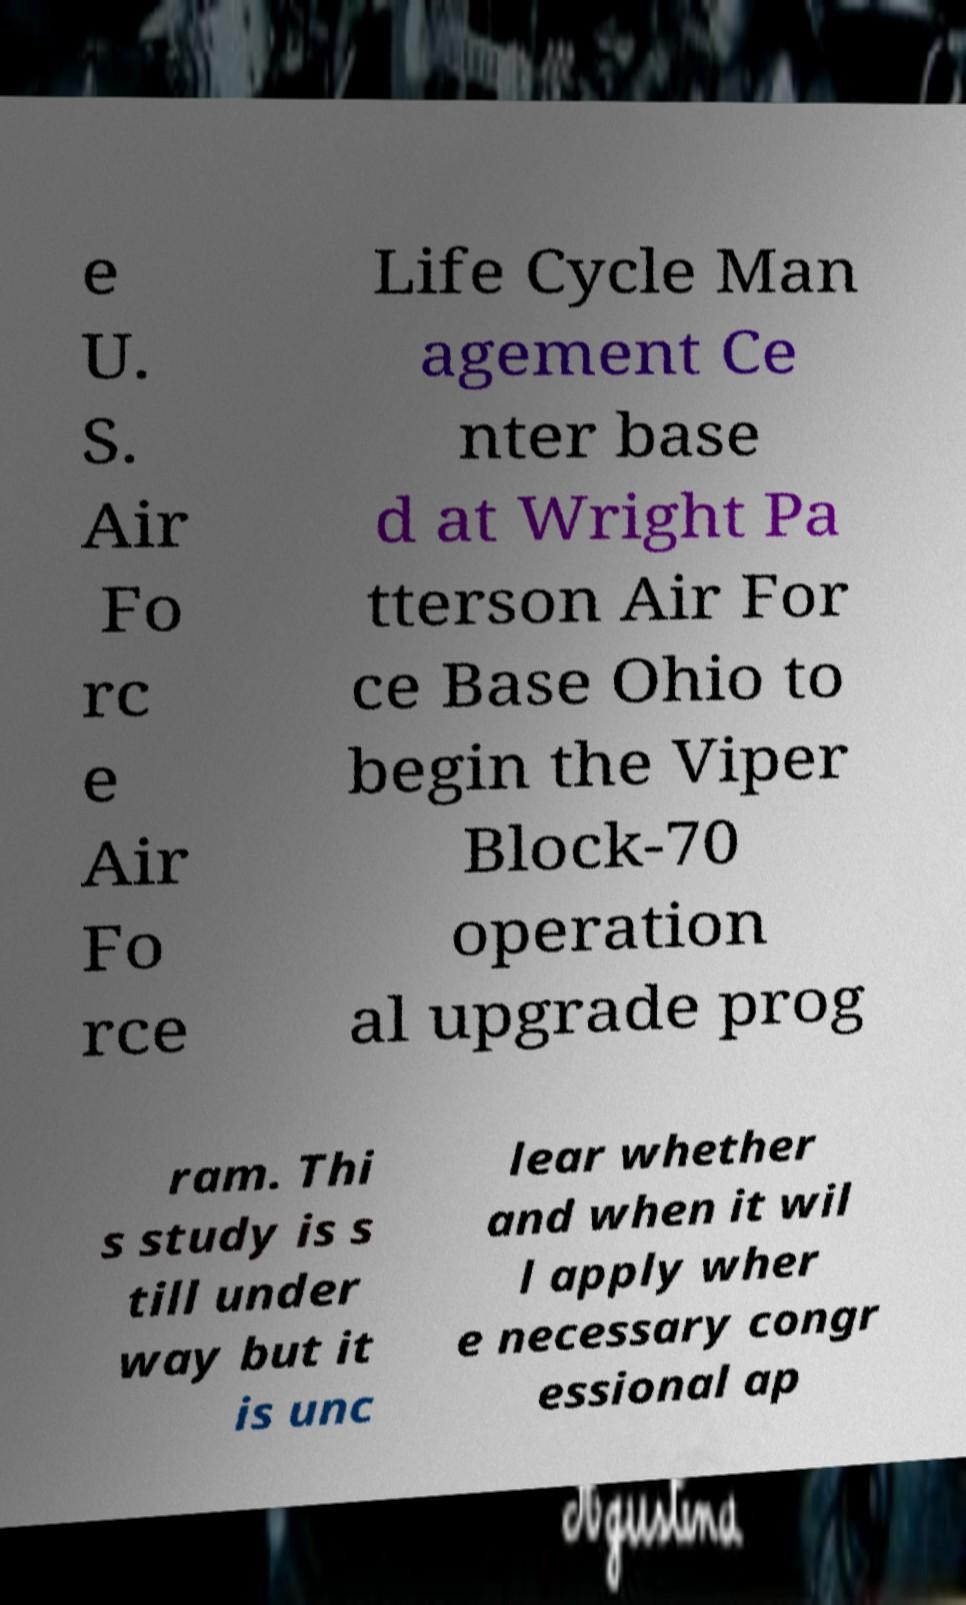Please identify and transcribe the text found in this image. e U. S. Air Fo rc e Air Fo rce Life Cycle Man agement Ce nter base d at Wright Pa tterson Air For ce Base Ohio to begin the Viper Block-70 operation al upgrade prog ram. Thi s study is s till under way but it is unc lear whether and when it wil l apply wher e necessary congr essional ap 